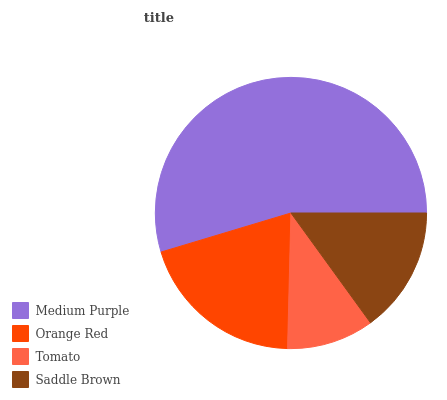Is Tomato the minimum?
Answer yes or no. Yes. Is Medium Purple the maximum?
Answer yes or no. Yes. Is Orange Red the minimum?
Answer yes or no. No. Is Orange Red the maximum?
Answer yes or no. No. Is Medium Purple greater than Orange Red?
Answer yes or no. Yes. Is Orange Red less than Medium Purple?
Answer yes or no. Yes. Is Orange Red greater than Medium Purple?
Answer yes or no. No. Is Medium Purple less than Orange Red?
Answer yes or no. No. Is Orange Red the high median?
Answer yes or no. Yes. Is Saddle Brown the low median?
Answer yes or no. Yes. Is Medium Purple the high median?
Answer yes or no. No. Is Tomato the low median?
Answer yes or no. No. 